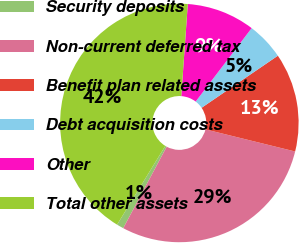Convert chart to OTSL. <chart><loc_0><loc_0><loc_500><loc_500><pie_chart><fcel>Security deposits<fcel>Non-current deferred tax<fcel>Benefit plan related assets<fcel>Debt acquisition costs<fcel>Other<fcel>Total other assets<nl><fcel>0.95%<fcel>28.95%<fcel>13.38%<fcel>5.1%<fcel>9.24%<fcel>42.38%<nl></chart> 